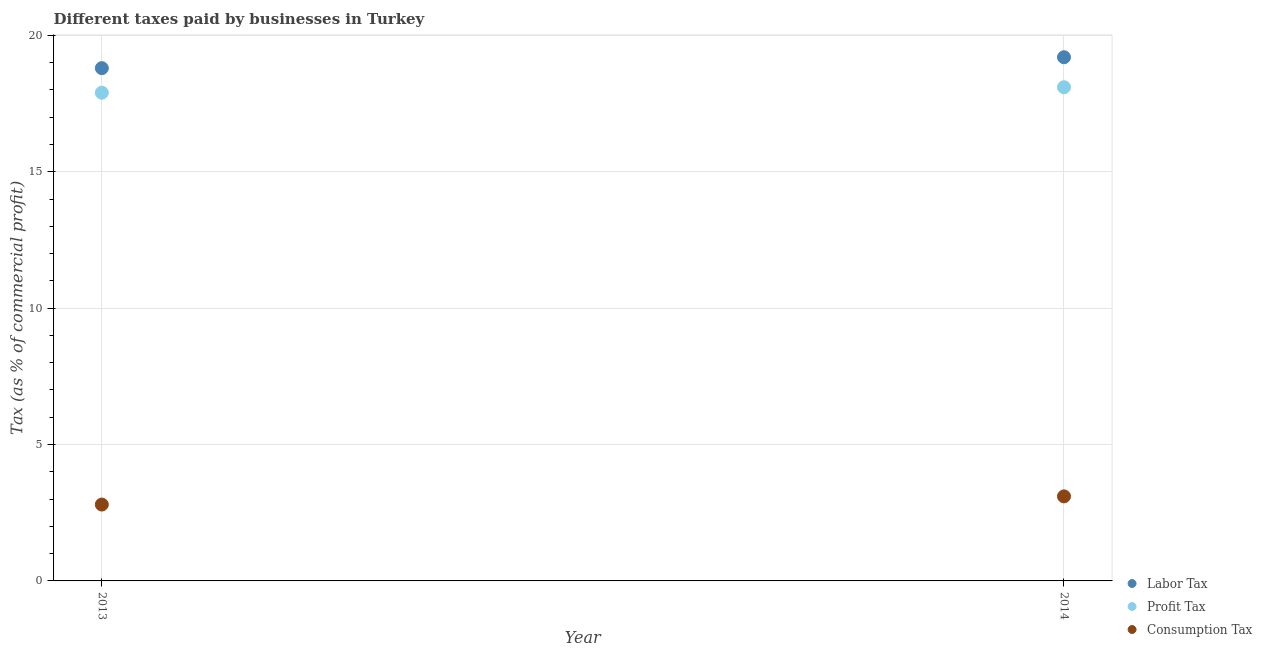How many different coloured dotlines are there?
Your answer should be very brief. 3. Is the number of dotlines equal to the number of legend labels?
Your answer should be very brief. Yes. Across all years, what is the maximum percentage of consumption tax?
Provide a succinct answer. 3.1. In which year was the percentage of labor tax maximum?
Provide a short and direct response. 2014. In which year was the percentage of labor tax minimum?
Your response must be concise. 2013. What is the difference between the percentage of profit tax in 2013 and that in 2014?
Ensure brevity in your answer.  -0.2. What is the difference between the percentage of consumption tax in 2014 and the percentage of profit tax in 2013?
Offer a very short reply. -14.8. In the year 2014, what is the difference between the percentage of profit tax and percentage of labor tax?
Provide a short and direct response. -1.1. In how many years, is the percentage of profit tax greater than 7 %?
Offer a terse response. 2. What is the ratio of the percentage of labor tax in 2013 to that in 2014?
Your response must be concise. 0.98. Is it the case that in every year, the sum of the percentage of labor tax and percentage of profit tax is greater than the percentage of consumption tax?
Ensure brevity in your answer.  Yes. Does the percentage of labor tax monotonically increase over the years?
Give a very brief answer. Yes. Is the percentage of consumption tax strictly less than the percentage of labor tax over the years?
Provide a short and direct response. Yes. How many years are there in the graph?
Your response must be concise. 2. Where does the legend appear in the graph?
Your answer should be very brief. Bottom right. What is the title of the graph?
Keep it short and to the point. Different taxes paid by businesses in Turkey. Does "Unemployment benefits" appear as one of the legend labels in the graph?
Give a very brief answer. No. What is the label or title of the X-axis?
Ensure brevity in your answer.  Year. What is the label or title of the Y-axis?
Offer a very short reply. Tax (as % of commercial profit). What is the Tax (as % of commercial profit) of Consumption Tax in 2013?
Your answer should be very brief. 2.8. What is the Tax (as % of commercial profit) in Profit Tax in 2014?
Make the answer very short. 18.1. Across all years, what is the maximum Tax (as % of commercial profit) of Profit Tax?
Your answer should be compact. 18.1. Across all years, what is the maximum Tax (as % of commercial profit) in Consumption Tax?
Keep it short and to the point. 3.1. What is the total Tax (as % of commercial profit) in Labor Tax in the graph?
Provide a succinct answer. 38. What is the difference between the Tax (as % of commercial profit) in Labor Tax in 2013 and that in 2014?
Make the answer very short. -0.4. What is the difference between the Tax (as % of commercial profit) in Consumption Tax in 2013 and that in 2014?
Your answer should be compact. -0.3. What is the difference between the Tax (as % of commercial profit) in Labor Tax in 2013 and the Tax (as % of commercial profit) in Consumption Tax in 2014?
Give a very brief answer. 15.7. What is the difference between the Tax (as % of commercial profit) in Profit Tax in 2013 and the Tax (as % of commercial profit) in Consumption Tax in 2014?
Give a very brief answer. 14.8. What is the average Tax (as % of commercial profit) in Consumption Tax per year?
Offer a very short reply. 2.95. In the year 2013, what is the difference between the Tax (as % of commercial profit) in Labor Tax and Tax (as % of commercial profit) in Profit Tax?
Keep it short and to the point. 0.9. In the year 2013, what is the difference between the Tax (as % of commercial profit) in Labor Tax and Tax (as % of commercial profit) in Consumption Tax?
Provide a short and direct response. 16. In the year 2014, what is the difference between the Tax (as % of commercial profit) of Labor Tax and Tax (as % of commercial profit) of Profit Tax?
Ensure brevity in your answer.  1.1. What is the ratio of the Tax (as % of commercial profit) in Labor Tax in 2013 to that in 2014?
Offer a terse response. 0.98. What is the ratio of the Tax (as % of commercial profit) of Consumption Tax in 2013 to that in 2014?
Provide a short and direct response. 0.9. What is the difference between the highest and the second highest Tax (as % of commercial profit) of Labor Tax?
Keep it short and to the point. 0.4. What is the difference between the highest and the second highest Tax (as % of commercial profit) in Profit Tax?
Offer a very short reply. 0.2. What is the difference between the highest and the lowest Tax (as % of commercial profit) in Labor Tax?
Your answer should be compact. 0.4. 